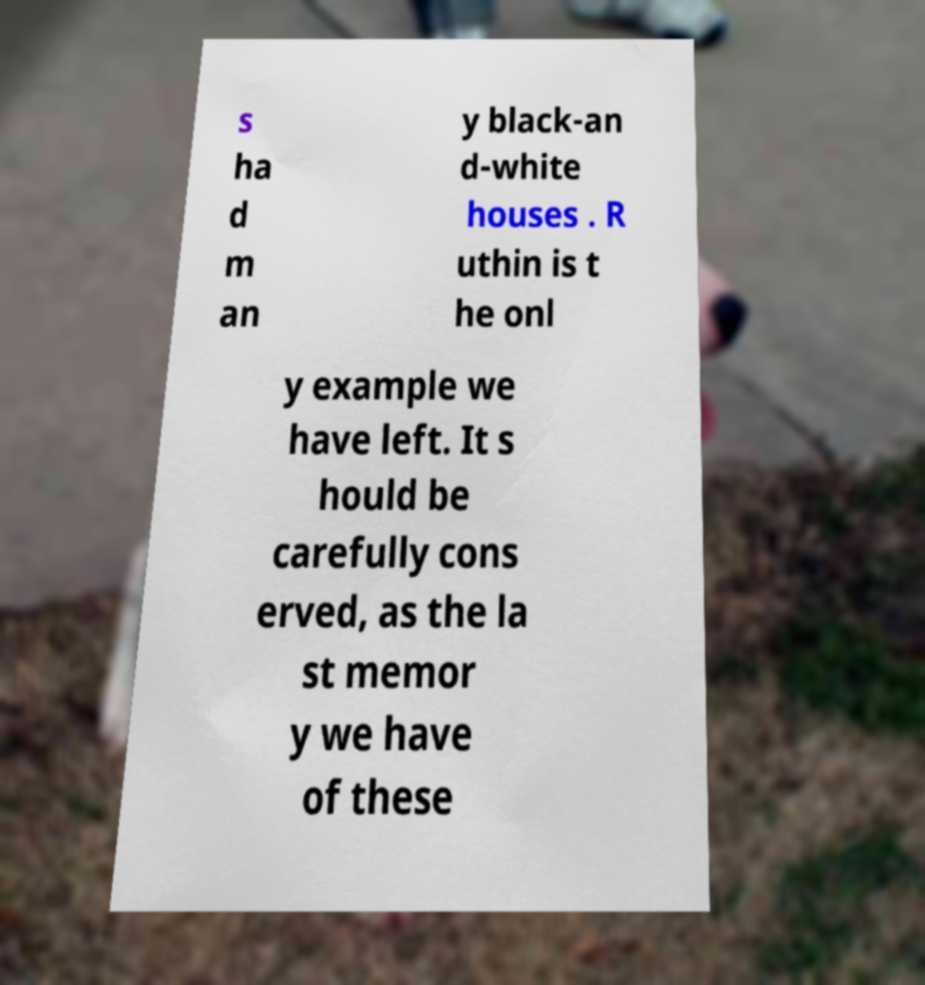Could you extract and type out the text from this image? s ha d m an y black-an d-white houses . R uthin is t he onl y example we have left. It s hould be carefully cons erved, as the la st memor y we have of these 